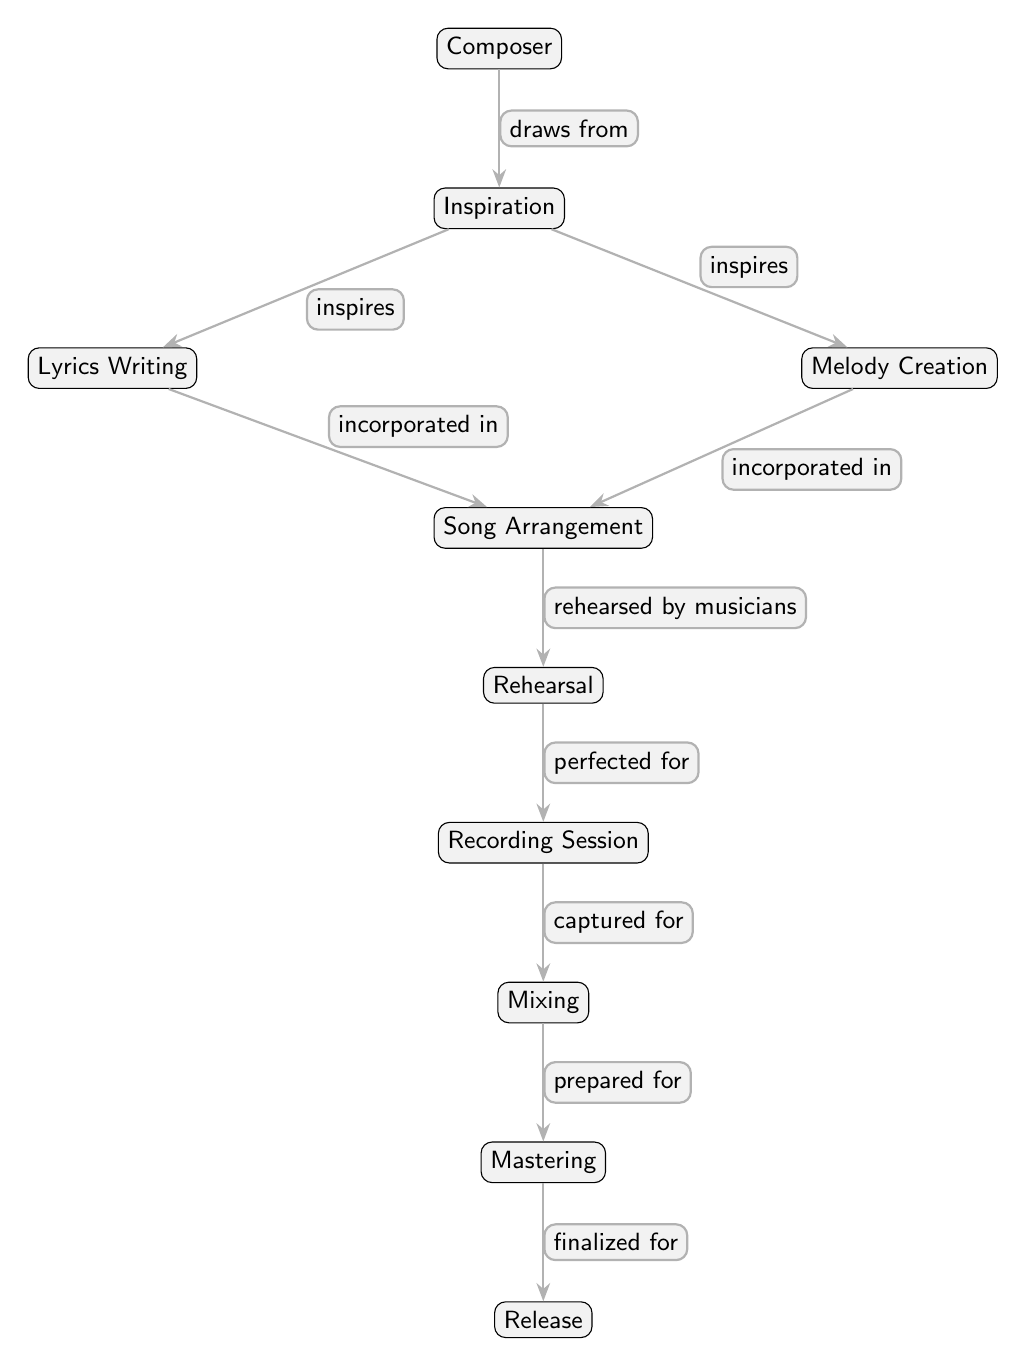What is the starting point of the evolution process? The diagram shows that the starting point of the evolution process is the "Composer." This is the first node that initiates the entire chain leading to the release of the acoustic song.
Answer: Composer How many nodes are present in the diagram? By counting the nodes visually depicted in the diagram, we identify a total of 10 distinct nodes that represent each step in the evolution of the acoustic song.
Answer: 10 What relationship does "Inspiration" have with "Lyrics Writing"? The diagram indicates that "Inspiration" directly "inspires" the "Lyrics Writing," showing a clear connection whereby inspiration leads to the creation of lyrics.
Answer: inspires Which step comes directly after "Rehearsal"? According to the flow of the diagram, "Recording Session" is the next step that follows "Rehearsal," representing the phase where the song is captured in its intended form.
Answer: Recording Session What are the final stages of the evolution process before release? The diagram outlines a sequence where "Mixing" follows "Recording Session," and then "Mastering" comes before the final step of "Release." These stages are crucial for preparing the song for distribution.
Answer: Mixing, Mastering In what way are "Lyrics Writing" and "Melody Creation" connected to "Song Arrangement"? Both "Lyrics Writing" and "Melody Creation" are shown to be "incorporated in" the "Song Arrangement." This indicates that these two components are foundational elements that contribute to the overall arrangement of the song.
Answer: incorporated in Which node indicates the final output of the process? The diagram clearly depicts "Release" as the final output of the entire process. This is where the song is made available to the public after all preceding steps have been completed.
Answer: Release What comes before the "Mixing" stage? According to the diagram flow, "Recording Session" is the stage that precedes "Mixing." This indicates that mixing occurs after the recording process has taken place.
Answer: Recording Session What is the role of "Composer" in this evolution process? "Composer" is the initiating figure in the diagram who draws inspiration, which sparks the various stages of song creation. The composer is key to starting the whole process.
Answer: draws from 